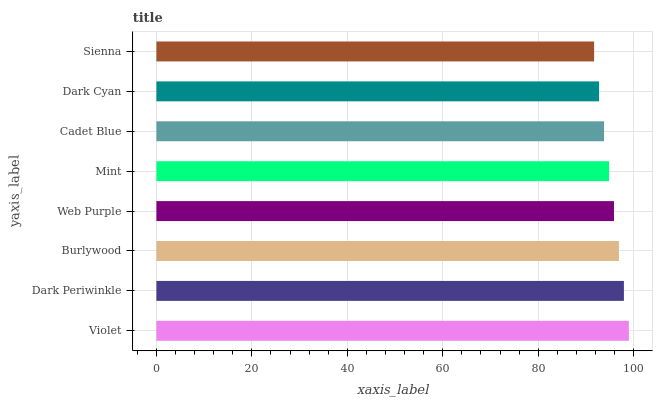Is Sienna the minimum?
Answer yes or no. Yes. Is Violet the maximum?
Answer yes or no. Yes. Is Dark Periwinkle the minimum?
Answer yes or no. No. Is Dark Periwinkle the maximum?
Answer yes or no. No. Is Violet greater than Dark Periwinkle?
Answer yes or no. Yes. Is Dark Periwinkle less than Violet?
Answer yes or no. Yes. Is Dark Periwinkle greater than Violet?
Answer yes or no. No. Is Violet less than Dark Periwinkle?
Answer yes or no. No. Is Web Purple the high median?
Answer yes or no. Yes. Is Mint the low median?
Answer yes or no. Yes. Is Burlywood the high median?
Answer yes or no. No. Is Dark Periwinkle the low median?
Answer yes or no. No. 